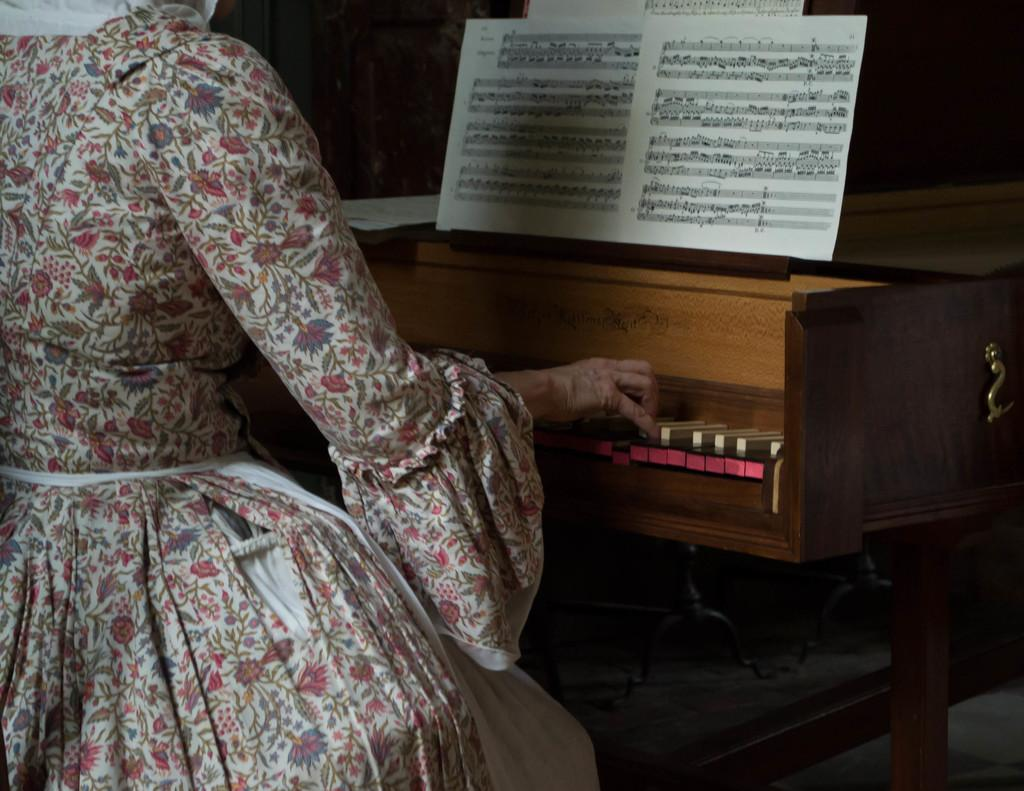Who is the main subject in the image? There is a woman in the image. What is the woman doing in the image? The woman is sitting on a chair and playing a piano. What can be seen on the piano? There are musical notes visible on the piano. What type of match is the woman holding in the image? There is no match present in the image; the woman is playing a piano. How does the rainstorm affect the woman's piano playing in the image? There is no rainstorm present in the image; it is an indoor scene with the woman playing the piano. 